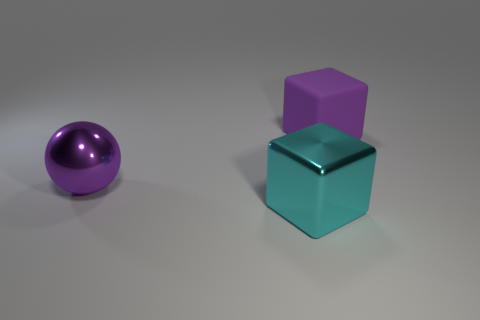What size is the thing that is the same color as the large sphere?
Your response must be concise. Large. Are there fewer large cyan shiny things than metal objects?
Provide a short and direct response. Yes. The cyan thing that is made of the same material as the ball is what size?
Your answer should be very brief. Large. What is the size of the sphere?
Give a very brief answer. Large. What is the shape of the large purple metallic object?
Your answer should be very brief. Sphere. Does the large shiny thing that is in front of the shiny ball have the same color as the big rubber block?
Make the answer very short. No. What size is the other rubber thing that is the same shape as the cyan thing?
Provide a short and direct response. Large. Is there any other thing that is made of the same material as the big purple block?
Make the answer very short. No. There is a large purple thing on the left side of the purple block behind the big shiny block; are there any metal spheres right of it?
Offer a very short reply. No. There is a purple thing in front of the big purple cube; what is it made of?
Make the answer very short. Metal. 